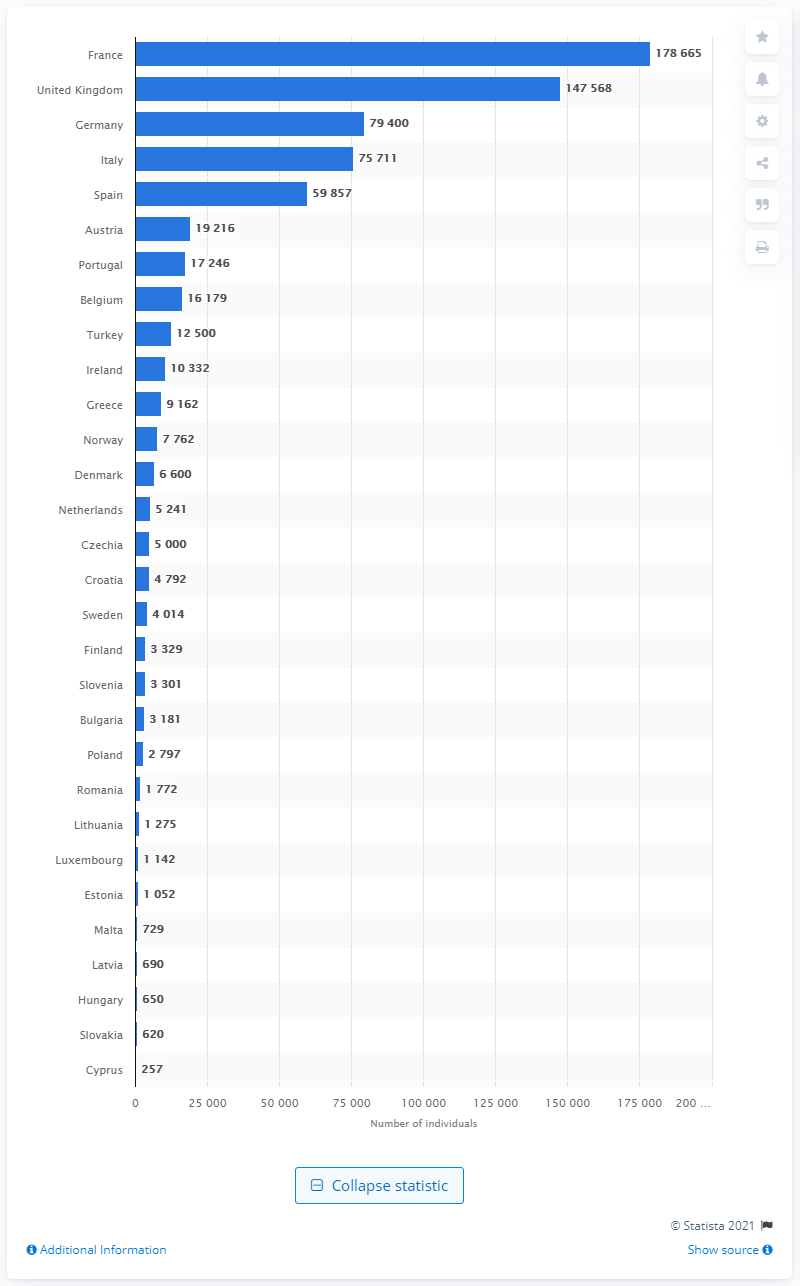List a handful of essential elements in this visual. In 2018, there were approximately 178,665 people in substitution treatment for opioid addiction in France. According to data from 2018, France had the largest number of individuals receiving treatment for opioid addiction through substitution therapy. The United Kingdom had the largest number of individuals receiving treatment for opioid addiction through substitution methods in 2018, according to recent data. 